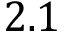<formula> <loc_0><loc_0><loc_500><loc_500>2 . 1</formula> 